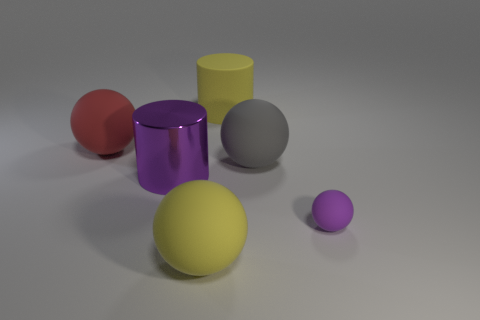Is there any other thing that has the same material as the big purple thing?
Provide a succinct answer. No. Is there any other thing that has the same size as the purple matte sphere?
Make the answer very short. No. Is the number of gray spheres greater than the number of red metallic things?
Your answer should be very brief. Yes. Is the small ball made of the same material as the yellow sphere?
Offer a very short reply. Yes. There is a tiny object that is the same material as the big red sphere; what is its shape?
Offer a terse response. Sphere. Are there fewer balls than tiny brown matte balls?
Offer a very short reply. No. What is the material of the large thing that is both behind the small purple ball and in front of the big gray rubber object?
Provide a short and direct response. Metal. There is a purple object right of the yellow thing that is behind the large gray matte object that is right of the large yellow ball; what size is it?
Ensure brevity in your answer.  Small. Does the big purple object have the same shape as the big thing that is to the left of the large purple cylinder?
Provide a succinct answer. No. How many yellow objects are both behind the red sphere and in front of the large rubber cylinder?
Provide a short and direct response. 0. 